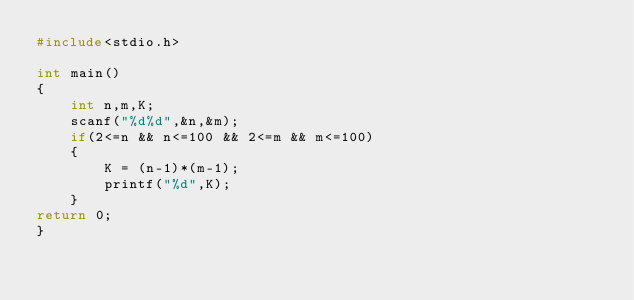Convert code to text. <code><loc_0><loc_0><loc_500><loc_500><_C_>#include<stdio.h>

int main()
{
    int n,m,K;
    scanf("%d%d",&n,&m);
    if(2<=n && n<=100 && 2<=m && m<=100)
    {
        K = (n-1)*(m-1);
        printf("%d",K);
    }
return 0;
}</code> 